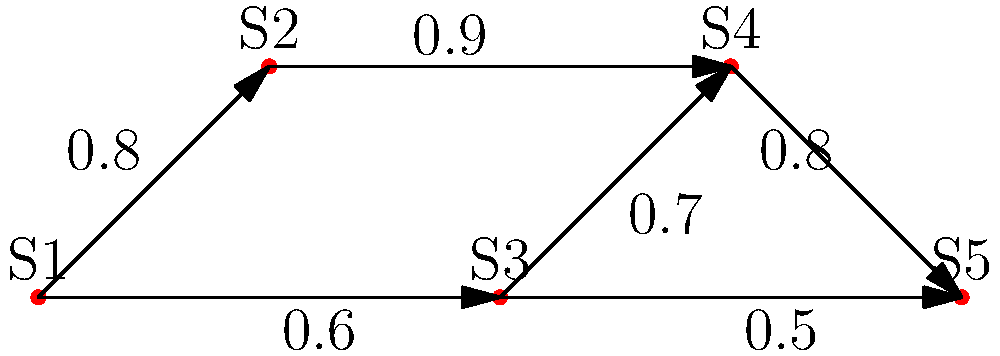In the graph representing source credibility and citation patterns in news articles, each node represents a source (S1 to S5), and edges represent citations with associated credibility scores. What is the most reliable path from source S1 to S5, and what is its overall credibility score? To find the most reliable path from S1 to S5 and calculate its overall credibility score, we need to follow these steps:

1. Identify all possible paths from S1 to S5:
   Path 1: S1 -> S2 -> S4 -> S5
   Path 2: S1 -> S3 -> S4 -> S5
   Path 3: S1 -> S3 -> S5

2. Calculate the overall credibility score for each path:
   - The overall credibility score is the product of individual edge scores along the path.
   
   Path 1: S1 -> S2 -> S4 -> S5
   Score = 0.8 * 0.9 * 0.8 = 0.576

   Path 2: S1 -> S3 -> S4 -> S5
   Score = 0.6 * 0.7 * 0.8 = 0.336

   Path 3: S1 -> S3 -> S5
   Score = 0.6 * 0.5 = 0.3

3. Compare the scores to find the most reliable path:
   Path 1: 0.576
   Path 2: 0.336
   Path 3: 0.3

The path with the highest overall credibility score is the most reliable path.
Answer: S1 -> S2 -> S4 -> S5; 0.576 